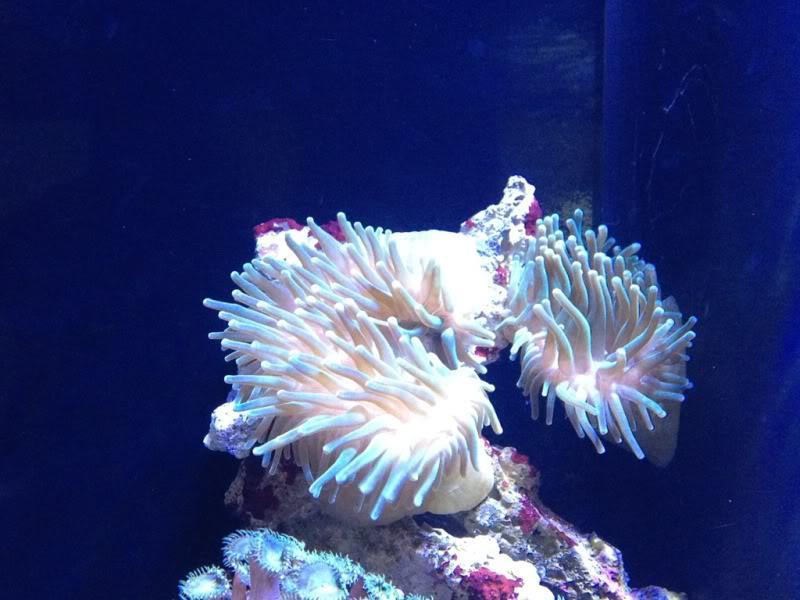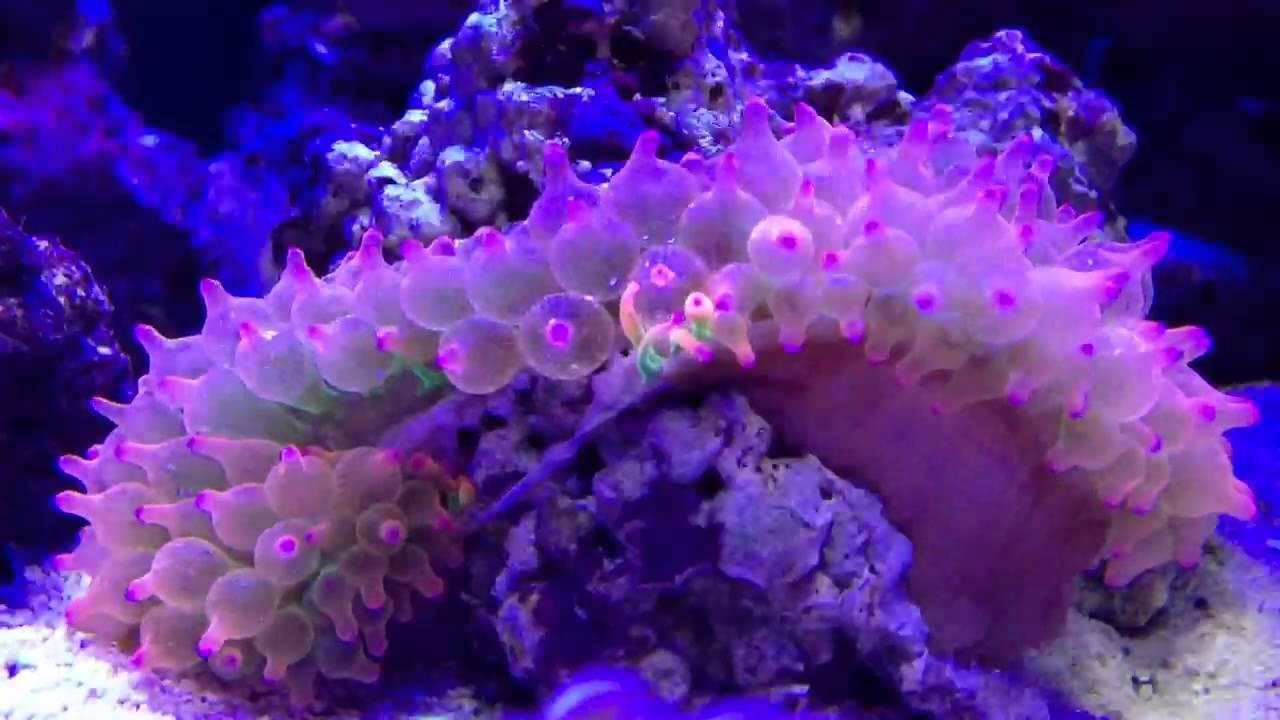The first image is the image on the left, the second image is the image on the right. Evaluate the accuracy of this statement regarding the images: "In at least one image there is a single  pink corral reef with and open oval circle in the middle of the reef facing up.". Is it true? Answer yes or no. No. The first image is the image on the left, the second image is the image on the right. Considering the images on both sides, is "One image shows anemone with bulbous pink tendrils, and the other image includes orange-and-white clownfish colors by anemone tendrils." valid? Answer yes or no. No. 